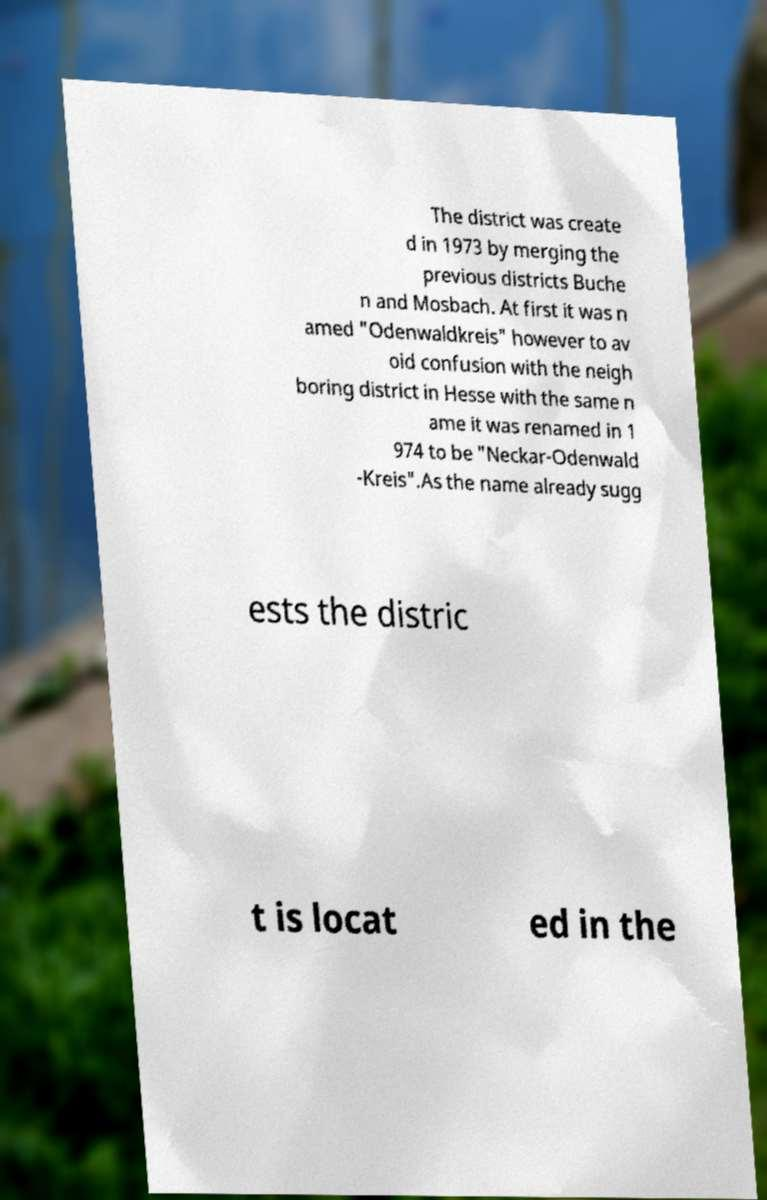There's text embedded in this image that I need extracted. Can you transcribe it verbatim? The district was create d in 1973 by merging the previous districts Buche n and Mosbach. At first it was n amed "Odenwaldkreis" however to av oid confusion with the neigh boring district in Hesse with the same n ame it was renamed in 1 974 to be "Neckar-Odenwald -Kreis".As the name already sugg ests the distric t is locat ed in the 